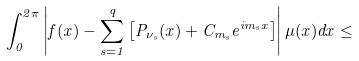Convert formula to latex. <formula><loc_0><loc_0><loc_500><loc_500>\int _ { 0 } ^ { 2 \pi } \left | f ( x ) - \sum _ { s = 1 } ^ { q } \left [ P _ { \nu _ { s } } ( x ) + C _ { m _ { s } } e ^ { i m _ { s } x } \right ] \right | \mu ( x ) d x \leq</formula> 